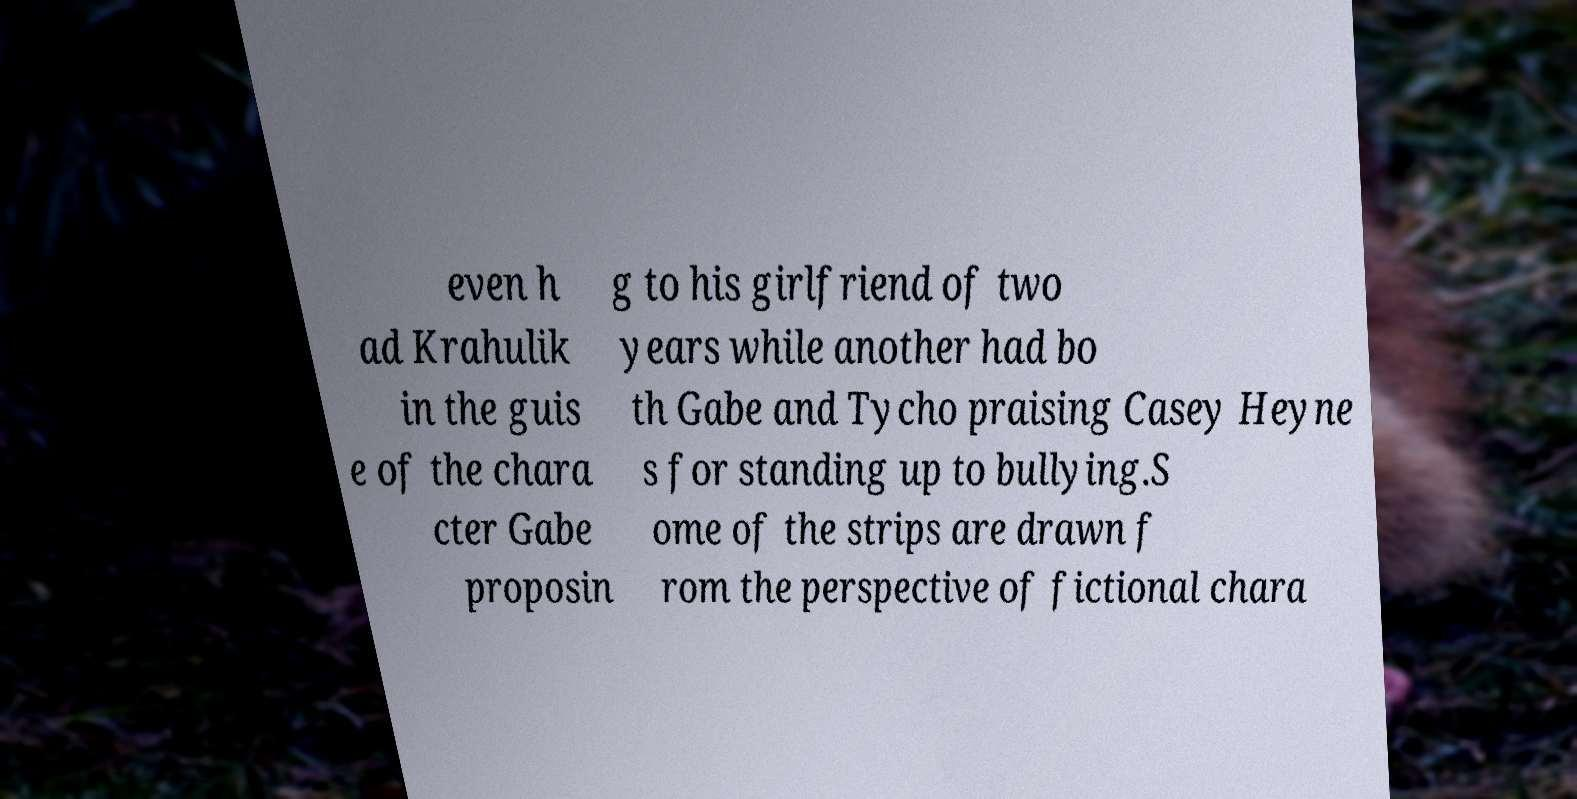There's text embedded in this image that I need extracted. Can you transcribe it verbatim? even h ad Krahulik in the guis e of the chara cter Gabe proposin g to his girlfriend of two years while another had bo th Gabe and Tycho praising Casey Heyne s for standing up to bullying.S ome of the strips are drawn f rom the perspective of fictional chara 